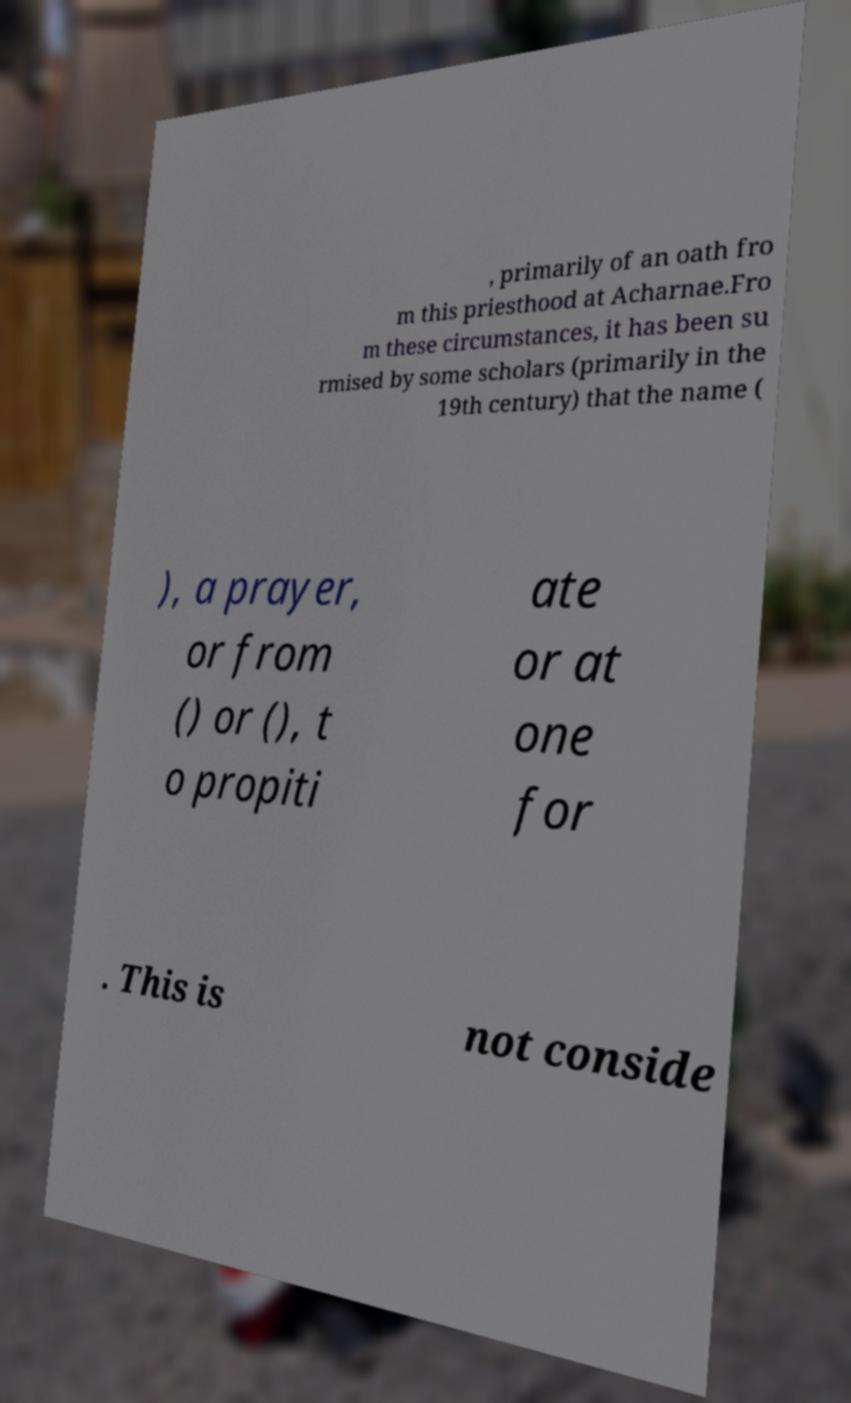For documentation purposes, I need the text within this image transcribed. Could you provide that? , primarily of an oath fro m this priesthood at Acharnae.Fro m these circumstances, it has been su rmised by some scholars (primarily in the 19th century) that the name ( ), a prayer, or from () or (), t o propiti ate or at one for . This is not conside 